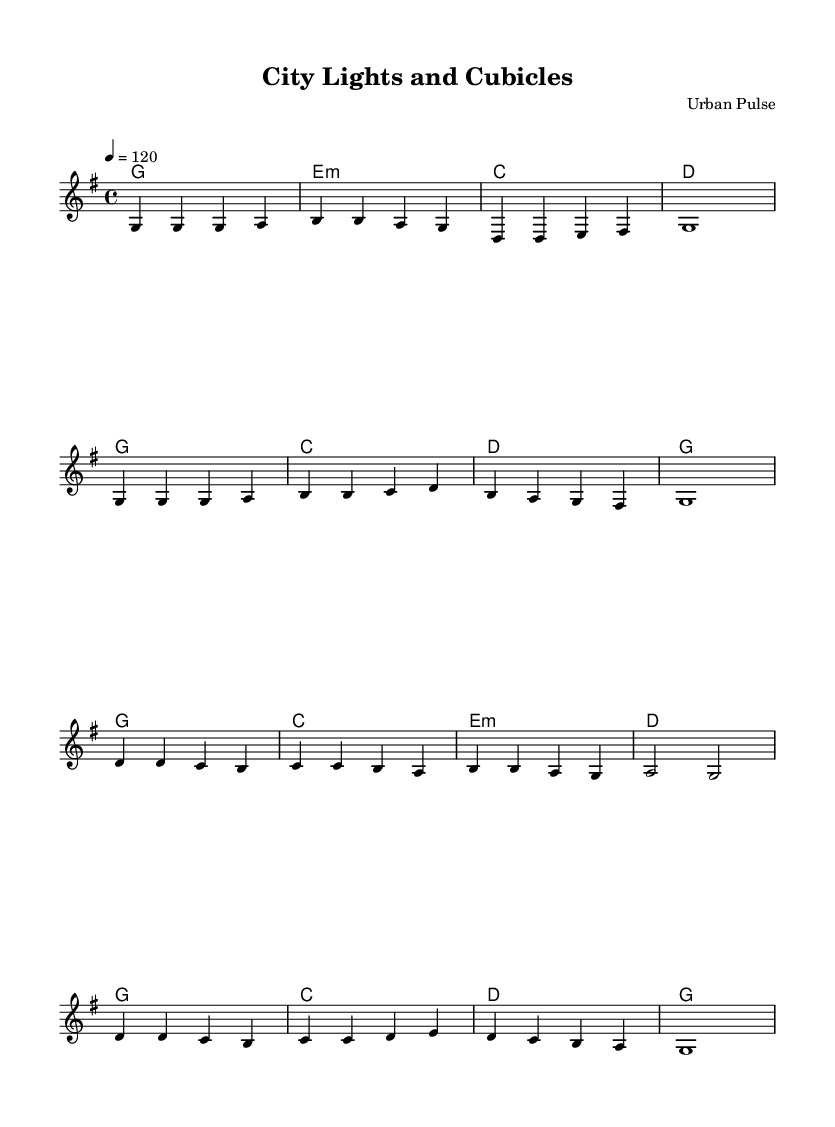What is the key signature of this music? The key signature indicated is G major, which has one sharp (F#) shown on the staff.
Answer: G major What is the time signature of the music? The time signature given in the music is 4/4, meaning there are four beats in each measure and the quarter note gets one beat, as seen at the beginning of the staff.
Answer: 4/4 What is the tempo marking for the piece? The tempo marking is indicated as 4 = 120, which means there are 120 quarter note beats per minute, showing the speed of the piece.
Answer: 120 How many measures are there in the verse? By counting the measures in the verse section provided, there are 8 measures for the verse indicated before the chorus.
Answer: 8 Which chord appears first in the harmony section? Looking at the harmony section, the first chord displayed is G, which is the chord played at the start of the music.
Answer: G What is the main theme of the chorus lyrics? The chorus lyrics focus on city life, mentioning "City lights and cubicles" which signifies the urban environment and professional lifestyle in an urban setting.
Answer: City life Which note is sustained at the end of the verse? The note that is held at the end of the verse is G, indicated by the whole note in that measure, suggesting a pause before transitioning to the chorus.
Answer: G 